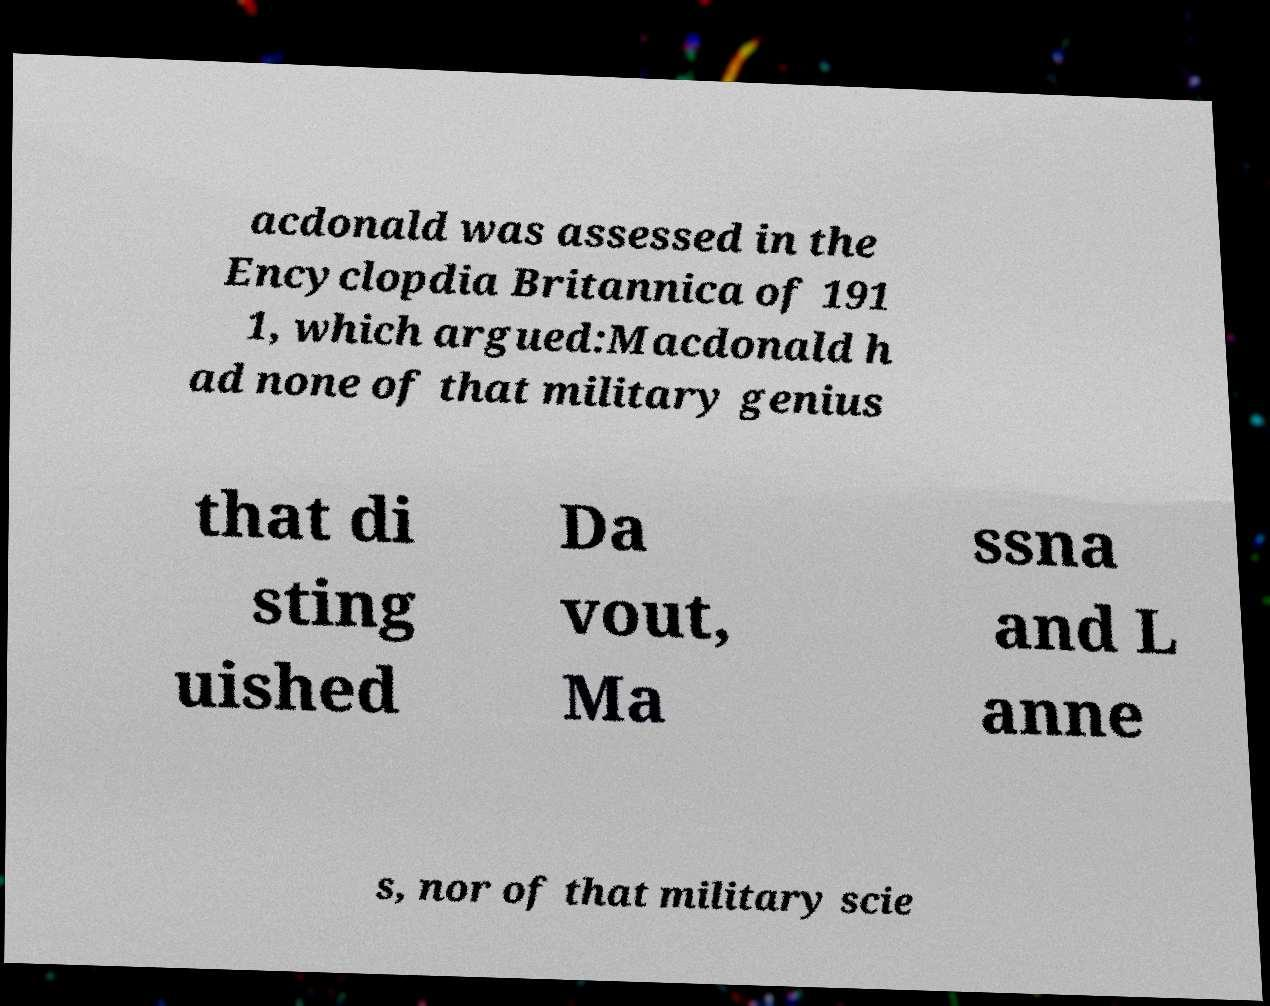Please read and relay the text visible in this image. What does it say? acdonald was assessed in the Encyclopdia Britannica of 191 1, which argued:Macdonald h ad none of that military genius that di sting uished Da vout, Ma ssna and L anne s, nor of that military scie 